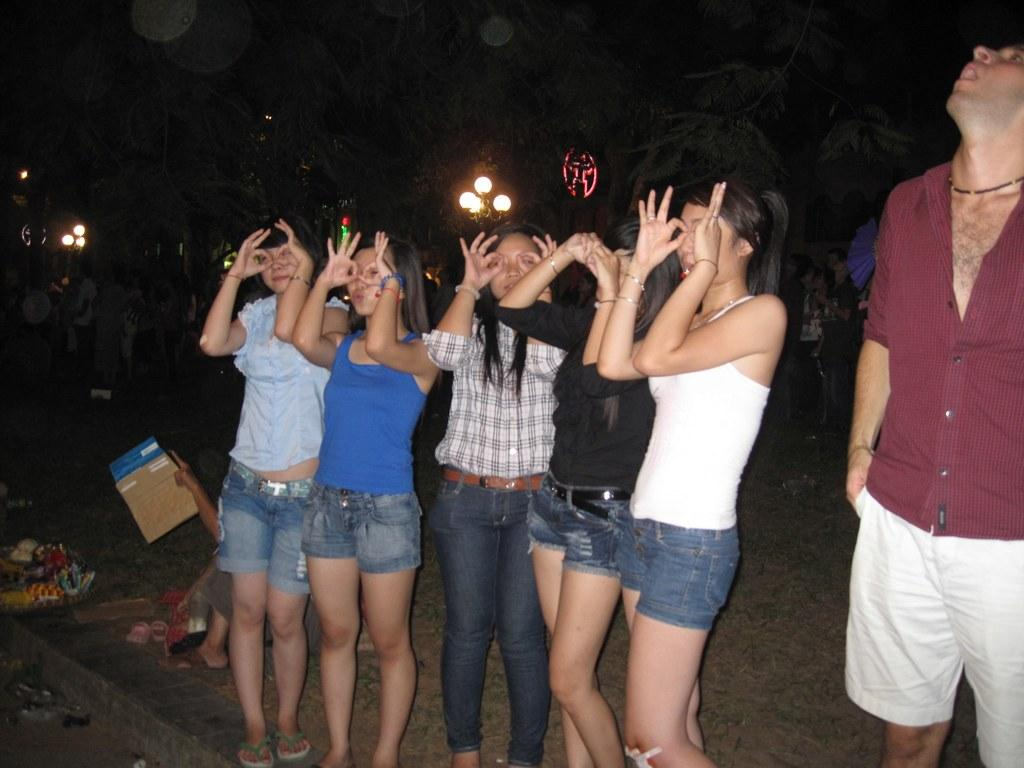What is the primary subject of the image? There is a person standing in the image. What is the person holding in the image? There is a person holding an object in the image. What type of natural environment is visible in the image? There are trees in the image. What type of artificial lighting is present in the image? There are lights in the image. What type of objects can be seen on the ground in the image? There are objects on the ground in the image. What type of pot is being used to comfort the person in the image? There is no pot visible in the image, nor is there any indication that the person is being comforted. 